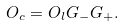<formula> <loc_0><loc_0><loc_500><loc_500>O _ { c } = O _ { l } G _ { - } G _ { + } .</formula> 